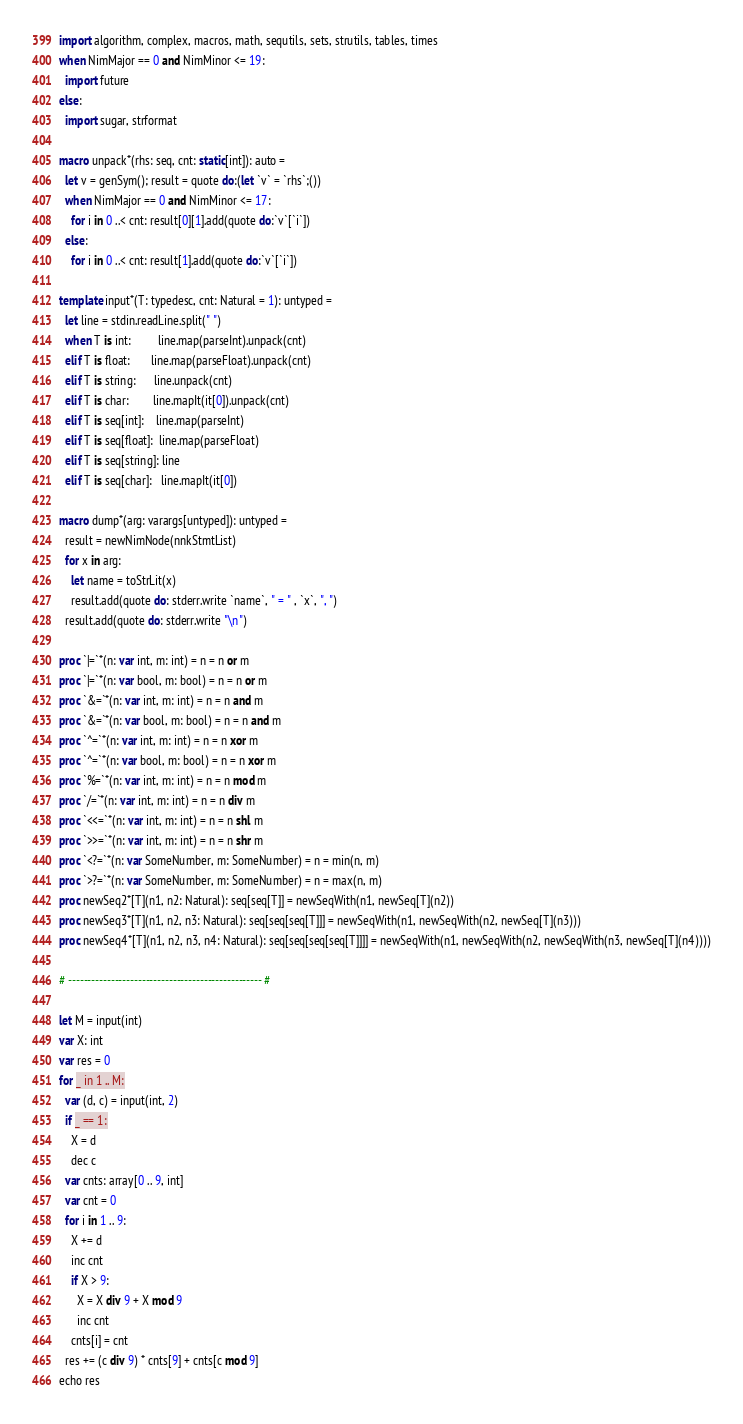Convert code to text. <code><loc_0><loc_0><loc_500><loc_500><_Nim_>import algorithm, complex, macros, math, sequtils, sets, strutils, tables, times
when NimMajor == 0 and NimMinor <= 19:
  import future
else:
  import sugar, strformat

macro unpack*(rhs: seq, cnt: static[int]): auto =
  let v = genSym(); result = quote do:(let `v` = `rhs`;())
  when NimMajor == 0 and NimMinor <= 17:
    for i in 0 ..< cnt: result[0][1].add(quote do:`v`[`i`])
  else:
    for i in 0 ..< cnt: result[1].add(quote do:`v`[`i`])

template input*(T: typedesc, cnt: Natural = 1): untyped =
  let line = stdin.readLine.split(" ")
  when T is int:         line.map(parseInt).unpack(cnt)
  elif T is float:       line.map(parseFloat).unpack(cnt)
  elif T is string:      line.unpack(cnt)
  elif T is char:        line.mapIt(it[0]).unpack(cnt)
  elif T is seq[int]:    line.map(parseInt)
  elif T is seq[float]:  line.map(parseFloat)
  elif T is seq[string]: line
  elif T is seq[char]:   line.mapIt(it[0])

macro dump*(arg: varargs[untyped]): untyped =
  result = newNimNode(nnkStmtList)
  for x in arg:
    let name = toStrLit(x)
    result.add(quote do: stderr.write `name`, " = " , `x`, ", ")
  result.add(quote do: stderr.write "\n")

proc `|=`*(n: var int, m: int) = n = n or m
proc `|=`*(n: var bool, m: bool) = n = n or m
proc `&=`*(n: var int, m: int) = n = n and m
proc `&=`*(n: var bool, m: bool) = n = n and m
proc `^=`*(n: var int, m: int) = n = n xor m
proc `^=`*(n: var bool, m: bool) = n = n xor m
proc `%=`*(n: var int, m: int) = n = n mod m
proc `/=`*(n: var int, m: int) = n = n div m
proc `<<=`*(n: var int, m: int) = n = n shl m
proc `>>=`*(n: var int, m: int) = n = n shr m
proc `<?=`*(n: var SomeNumber, m: SomeNumber) = n = min(n, m)
proc `>?=`*(n: var SomeNumber, m: SomeNumber) = n = max(n, m)
proc newSeq2*[T](n1, n2: Natural): seq[seq[T]] = newSeqWith(n1, newSeq[T](n2))
proc newSeq3*[T](n1, n2, n3: Natural): seq[seq[seq[T]]] = newSeqWith(n1, newSeqWith(n2, newSeq[T](n3)))
proc newSeq4*[T](n1, n2, n3, n4: Natural): seq[seq[seq[seq[T]]]] = newSeqWith(n1, newSeqWith(n2, newSeqWith(n3, newSeq[T](n4))))

# -------------------------------------------------- #

let M = input(int)
var X: int
var res = 0
for _ in 1 .. M:
  var (d, c) = input(int, 2)
  if _ == 1:
    X = d
    dec c
  var cnts: array[0 .. 9, int]
  var cnt = 0
  for i in 1 .. 9:
    X += d
    inc cnt
    if X > 9:
      X = X div 9 + X mod 9
      inc cnt
    cnts[i] = cnt
  res += (c div 9) * cnts[9] + cnts[c mod 9]
echo res</code> 